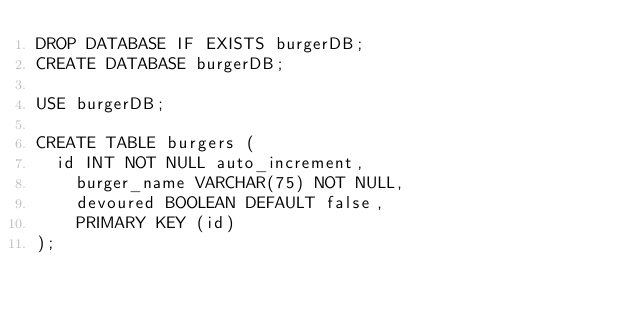Convert code to text. <code><loc_0><loc_0><loc_500><loc_500><_SQL_>DROP DATABASE IF EXISTS burgerDB;
CREATE DATABASE burgerDB;

USE burgerDB;

CREATE TABLE burgers (
	id INT NOT NULL auto_increment,
    burger_name VARCHAR(75) NOT NULL,
    devoured BOOLEAN DEFAULT false,
    PRIMARY KEY (id)
);</code> 